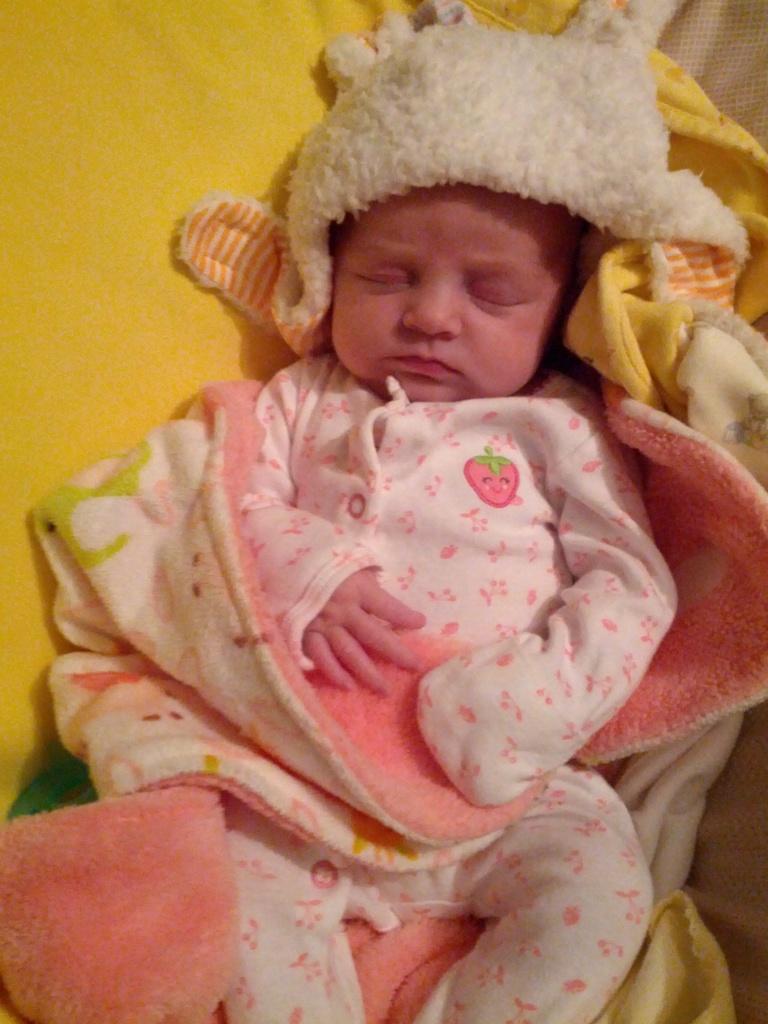In one or two sentences, can you explain what this image depicts? In this image I can see a baby sleeping. In the background, I can see a yellow colored cloth. 